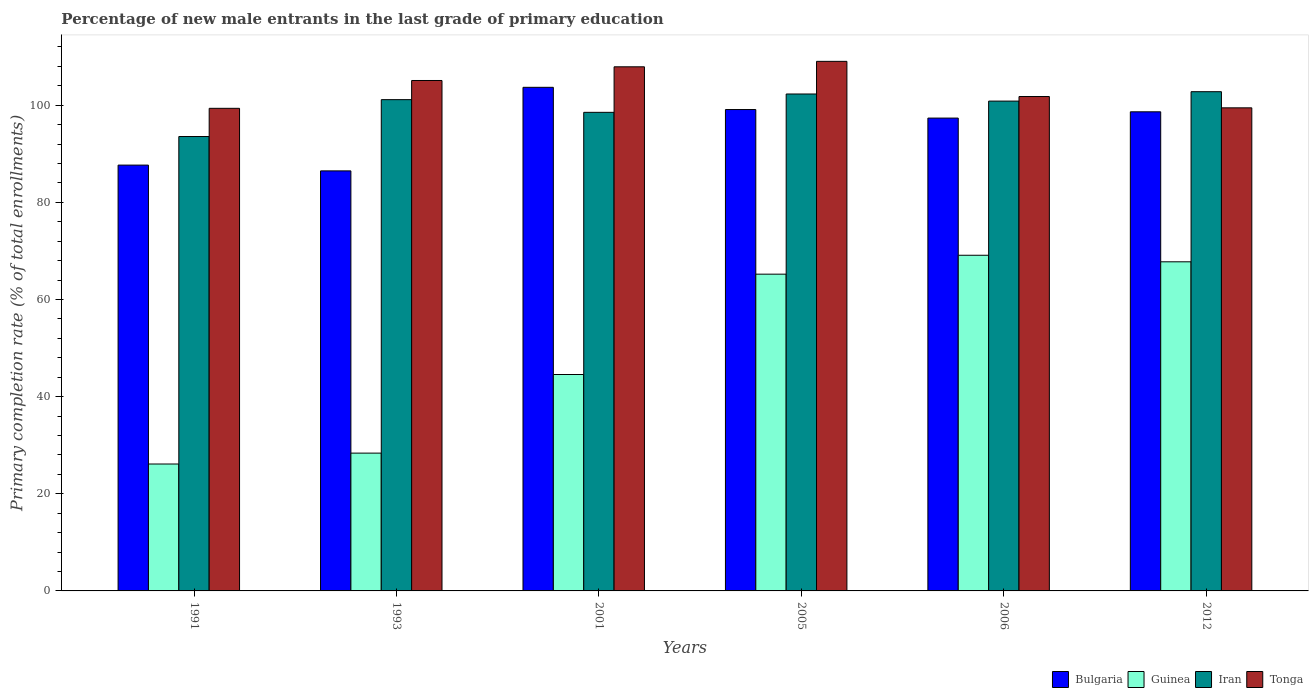How many different coloured bars are there?
Make the answer very short. 4. How many groups of bars are there?
Make the answer very short. 6. What is the label of the 1st group of bars from the left?
Your response must be concise. 1991. In how many cases, is the number of bars for a given year not equal to the number of legend labels?
Your answer should be compact. 0. What is the percentage of new male entrants in Tonga in 2012?
Give a very brief answer. 99.47. Across all years, what is the maximum percentage of new male entrants in Iran?
Your response must be concise. 102.79. Across all years, what is the minimum percentage of new male entrants in Bulgaria?
Provide a succinct answer. 86.49. In which year was the percentage of new male entrants in Bulgaria minimum?
Make the answer very short. 1993. What is the total percentage of new male entrants in Iran in the graph?
Your answer should be compact. 599.23. What is the difference between the percentage of new male entrants in Guinea in 2005 and that in 2006?
Provide a succinct answer. -3.9. What is the difference between the percentage of new male entrants in Guinea in 2005 and the percentage of new male entrants in Iran in 2012?
Your response must be concise. -37.57. What is the average percentage of new male entrants in Tonga per year?
Keep it short and to the point. 103.78. In the year 2012, what is the difference between the percentage of new male entrants in Iran and percentage of new male entrants in Tonga?
Your answer should be very brief. 3.32. In how many years, is the percentage of new male entrants in Iran greater than 108 %?
Offer a very short reply. 0. What is the ratio of the percentage of new male entrants in Guinea in 2001 to that in 2012?
Offer a very short reply. 0.66. What is the difference between the highest and the second highest percentage of new male entrants in Guinea?
Your answer should be very brief. 1.35. What is the difference between the highest and the lowest percentage of new male entrants in Iran?
Offer a terse response. 9.23. In how many years, is the percentage of new male entrants in Guinea greater than the average percentage of new male entrants in Guinea taken over all years?
Keep it short and to the point. 3. What does the 3rd bar from the left in 2006 represents?
Your response must be concise. Iran. What does the 3rd bar from the right in 2012 represents?
Your answer should be compact. Guinea. How many years are there in the graph?
Offer a terse response. 6. Are the values on the major ticks of Y-axis written in scientific E-notation?
Make the answer very short. No. Does the graph contain grids?
Offer a very short reply. No. How many legend labels are there?
Ensure brevity in your answer.  4. How are the legend labels stacked?
Provide a short and direct response. Horizontal. What is the title of the graph?
Provide a short and direct response. Percentage of new male entrants in the last grade of primary education. What is the label or title of the Y-axis?
Your answer should be very brief. Primary completion rate (% of total enrollments). What is the Primary completion rate (% of total enrollments) of Bulgaria in 1991?
Your answer should be compact. 87.68. What is the Primary completion rate (% of total enrollments) in Guinea in 1991?
Offer a terse response. 26.13. What is the Primary completion rate (% of total enrollments) of Iran in 1991?
Provide a succinct answer. 93.56. What is the Primary completion rate (% of total enrollments) in Tonga in 1991?
Keep it short and to the point. 99.37. What is the Primary completion rate (% of total enrollments) of Bulgaria in 1993?
Make the answer very short. 86.49. What is the Primary completion rate (% of total enrollments) of Guinea in 1993?
Offer a terse response. 28.37. What is the Primary completion rate (% of total enrollments) of Iran in 1993?
Keep it short and to the point. 101.15. What is the Primary completion rate (% of total enrollments) in Tonga in 1993?
Ensure brevity in your answer.  105.1. What is the Primary completion rate (% of total enrollments) of Bulgaria in 2001?
Your response must be concise. 103.7. What is the Primary completion rate (% of total enrollments) in Guinea in 2001?
Your answer should be very brief. 44.56. What is the Primary completion rate (% of total enrollments) in Iran in 2001?
Offer a terse response. 98.54. What is the Primary completion rate (% of total enrollments) of Tonga in 2001?
Ensure brevity in your answer.  107.92. What is the Primary completion rate (% of total enrollments) in Bulgaria in 2005?
Your answer should be very brief. 99.12. What is the Primary completion rate (% of total enrollments) in Guinea in 2005?
Your answer should be very brief. 65.22. What is the Primary completion rate (% of total enrollments) of Iran in 2005?
Provide a succinct answer. 102.32. What is the Primary completion rate (% of total enrollments) in Tonga in 2005?
Keep it short and to the point. 109.04. What is the Primary completion rate (% of total enrollments) in Bulgaria in 2006?
Provide a succinct answer. 97.36. What is the Primary completion rate (% of total enrollments) in Guinea in 2006?
Provide a short and direct response. 69.12. What is the Primary completion rate (% of total enrollments) in Iran in 2006?
Keep it short and to the point. 100.86. What is the Primary completion rate (% of total enrollments) in Tonga in 2006?
Your response must be concise. 101.8. What is the Primary completion rate (% of total enrollments) in Bulgaria in 2012?
Your answer should be very brief. 98.65. What is the Primary completion rate (% of total enrollments) of Guinea in 2012?
Ensure brevity in your answer.  67.77. What is the Primary completion rate (% of total enrollments) in Iran in 2012?
Your response must be concise. 102.79. What is the Primary completion rate (% of total enrollments) in Tonga in 2012?
Your answer should be very brief. 99.47. Across all years, what is the maximum Primary completion rate (% of total enrollments) in Bulgaria?
Your response must be concise. 103.7. Across all years, what is the maximum Primary completion rate (% of total enrollments) in Guinea?
Offer a terse response. 69.12. Across all years, what is the maximum Primary completion rate (% of total enrollments) in Iran?
Your answer should be compact. 102.79. Across all years, what is the maximum Primary completion rate (% of total enrollments) in Tonga?
Your response must be concise. 109.04. Across all years, what is the minimum Primary completion rate (% of total enrollments) of Bulgaria?
Give a very brief answer. 86.49. Across all years, what is the minimum Primary completion rate (% of total enrollments) of Guinea?
Your answer should be very brief. 26.13. Across all years, what is the minimum Primary completion rate (% of total enrollments) of Iran?
Your answer should be compact. 93.56. Across all years, what is the minimum Primary completion rate (% of total enrollments) of Tonga?
Keep it short and to the point. 99.37. What is the total Primary completion rate (% of total enrollments) of Bulgaria in the graph?
Ensure brevity in your answer.  572.99. What is the total Primary completion rate (% of total enrollments) in Guinea in the graph?
Keep it short and to the point. 301.17. What is the total Primary completion rate (% of total enrollments) of Iran in the graph?
Give a very brief answer. 599.23. What is the total Primary completion rate (% of total enrollments) in Tonga in the graph?
Make the answer very short. 622.7. What is the difference between the Primary completion rate (% of total enrollments) in Bulgaria in 1991 and that in 1993?
Ensure brevity in your answer.  1.19. What is the difference between the Primary completion rate (% of total enrollments) of Guinea in 1991 and that in 1993?
Offer a terse response. -2.24. What is the difference between the Primary completion rate (% of total enrollments) in Iran in 1991 and that in 1993?
Your answer should be compact. -7.59. What is the difference between the Primary completion rate (% of total enrollments) of Tonga in 1991 and that in 1993?
Give a very brief answer. -5.73. What is the difference between the Primary completion rate (% of total enrollments) in Bulgaria in 1991 and that in 2001?
Your answer should be compact. -16.02. What is the difference between the Primary completion rate (% of total enrollments) of Guinea in 1991 and that in 2001?
Keep it short and to the point. -18.43. What is the difference between the Primary completion rate (% of total enrollments) of Iran in 1991 and that in 2001?
Your response must be concise. -4.98. What is the difference between the Primary completion rate (% of total enrollments) of Tonga in 1991 and that in 2001?
Your answer should be very brief. -8.55. What is the difference between the Primary completion rate (% of total enrollments) in Bulgaria in 1991 and that in 2005?
Your answer should be very brief. -11.44. What is the difference between the Primary completion rate (% of total enrollments) of Guinea in 1991 and that in 2005?
Your response must be concise. -39.09. What is the difference between the Primary completion rate (% of total enrollments) in Iran in 1991 and that in 2005?
Your response must be concise. -8.76. What is the difference between the Primary completion rate (% of total enrollments) of Tonga in 1991 and that in 2005?
Ensure brevity in your answer.  -9.67. What is the difference between the Primary completion rate (% of total enrollments) of Bulgaria in 1991 and that in 2006?
Make the answer very short. -9.68. What is the difference between the Primary completion rate (% of total enrollments) in Guinea in 1991 and that in 2006?
Your answer should be very brief. -42.98. What is the difference between the Primary completion rate (% of total enrollments) of Iran in 1991 and that in 2006?
Provide a short and direct response. -7.29. What is the difference between the Primary completion rate (% of total enrollments) in Tonga in 1991 and that in 2006?
Make the answer very short. -2.43. What is the difference between the Primary completion rate (% of total enrollments) in Bulgaria in 1991 and that in 2012?
Make the answer very short. -10.97. What is the difference between the Primary completion rate (% of total enrollments) in Guinea in 1991 and that in 2012?
Offer a terse response. -41.63. What is the difference between the Primary completion rate (% of total enrollments) in Iran in 1991 and that in 2012?
Offer a terse response. -9.23. What is the difference between the Primary completion rate (% of total enrollments) of Tonga in 1991 and that in 2012?
Ensure brevity in your answer.  -0.1. What is the difference between the Primary completion rate (% of total enrollments) of Bulgaria in 1993 and that in 2001?
Your answer should be very brief. -17.21. What is the difference between the Primary completion rate (% of total enrollments) of Guinea in 1993 and that in 2001?
Your answer should be compact. -16.19. What is the difference between the Primary completion rate (% of total enrollments) of Iran in 1993 and that in 2001?
Offer a very short reply. 2.61. What is the difference between the Primary completion rate (% of total enrollments) of Tonga in 1993 and that in 2001?
Offer a terse response. -2.82. What is the difference between the Primary completion rate (% of total enrollments) of Bulgaria in 1993 and that in 2005?
Offer a very short reply. -12.63. What is the difference between the Primary completion rate (% of total enrollments) in Guinea in 1993 and that in 2005?
Make the answer very short. -36.85. What is the difference between the Primary completion rate (% of total enrollments) of Iran in 1993 and that in 2005?
Your response must be concise. -1.16. What is the difference between the Primary completion rate (% of total enrollments) of Tonga in 1993 and that in 2005?
Your answer should be very brief. -3.94. What is the difference between the Primary completion rate (% of total enrollments) in Bulgaria in 1993 and that in 2006?
Your answer should be compact. -10.87. What is the difference between the Primary completion rate (% of total enrollments) of Guinea in 1993 and that in 2006?
Provide a short and direct response. -40.74. What is the difference between the Primary completion rate (% of total enrollments) of Iran in 1993 and that in 2006?
Ensure brevity in your answer.  0.3. What is the difference between the Primary completion rate (% of total enrollments) in Tonga in 1993 and that in 2006?
Your answer should be compact. 3.3. What is the difference between the Primary completion rate (% of total enrollments) in Bulgaria in 1993 and that in 2012?
Your answer should be compact. -12.16. What is the difference between the Primary completion rate (% of total enrollments) in Guinea in 1993 and that in 2012?
Provide a short and direct response. -39.39. What is the difference between the Primary completion rate (% of total enrollments) in Iran in 1993 and that in 2012?
Make the answer very short. -1.64. What is the difference between the Primary completion rate (% of total enrollments) in Tonga in 1993 and that in 2012?
Offer a very short reply. 5.63. What is the difference between the Primary completion rate (% of total enrollments) of Bulgaria in 2001 and that in 2005?
Keep it short and to the point. 4.58. What is the difference between the Primary completion rate (% of total enrollments) of Guinea in 2001 and that in 2005?
Your answer should be very brief. -20.66. What is the difference between the Primary completion rate (% of total enrollments) of Iran in 2001 and that in 2005?
Provide a succinct answer. -3.78. What is the difference between the Primary completion rate (% of total enrollments) in Tonga in 2001 and that in 2005?
Ensure brevity in your answer.  -1.12. What is the difference between the Primary completion rate (% of total enrollments) in Bulgaria in 2001 and that in 2006?
Your answer should be compact. 6.34. What is the difference between the Primary completion rate (% of total enrollments) in Guinea in 2001 and that in 2006?
Make the answer very short. -24.56. What is the difference between the Primary completion rate (% of total enrollments) of Iran in 2001 and that in 2006?
Offer a very short reply. -2.31. What is the difference between the Primary completion rate (% of total enrollments) in Tonga in 2001 and that in 2006?
Provide a succinct answer. 6.12. What is the difference between the Primary completion rate (% of total enrollments) in Bulgaria in 2001 and that in 2012?
Provide a succinct answer. 5.04. What is the difference between the Primary completion rate (% of total enrollments) in Guinea in 2001 and that in 2012?
Offer a very short reply. -23.21. What is the difference between the Primary completion rate (% of total enrollments) in Iran in 2001 and that in 2012?
Make the answer very short. -4.25. What is the difference between the Primary completion rate (% of total enrollments) in Tonga in 2001 and that in 2012?
Provide a short and direct response. 8.45. What is the difference between the Primary completion rate (% of total enrollments) of Bulgaria in 2005 and that in 2006?
Provide a short and direct response. 1.76. What is the difference between the Primary completion rate (% of total enrollments) of Guinea in 2005 and that in 2006?
Offer a terse response. -3.9. What is the difference between the Primary completion rate (% of total enrollments) of Iran in 2005 and that in 2006?
Your response must be concise. 1.46. What is the difference between the Primary completion rate (% of total enrollments) in Tonga in 2005 and that in 2006?
Your response must be concise. 7.24. What is the difference between the Primary completion rate (% of total enrollments) of Bulgaria in 2005 and that in 2012?
Your answer should be compact. 0.47. What is the difference between the Primary completion rate (% of total enrollments) of Guinea in 2005 and that in 2012?
Offer a very short reply. -2.55. What is the difference between the Primary completion rate (% of total enrollments) in Iran in 2005 and that in 2012?
Give a very brief answer. -0.47. What is the difference between the Primary completion rate (% of total enrollments) in Tonga in 2005 and that in 2012?
Your response must be concise. 9.57. What is the difference between the Primary completion rate (% of total enrollments) of Bulgaria in 2006 and that in 2012?
Ensure brevity in your answer.  -1.29. What is the difference between the Primary completion rate (% of total enrollments) of Guinea in 2006 and that in 2012?
Give a very brief answer. 1.35. What is the difference between the Primary completion rate (% of total enrollments) in Iran in 2006 and that in 2012?
Offer a terse response. -1.94. What is the difference between the Primary completion rate (% of total enrollments) in Tonga in 2006 and that in 2012?
Offer a terse response. 2.33. What is the difference between the Primary completion rate (% of total enrollments) in Bulgaria in 1991 and the Primary completion rate (% of total enrollments) in Guinea in 1993?
Keep it short and to the point. 59.31. What is the difference between the Primary completion rate (% of total enrollments) in Bulgaria in 1991 and the Primary completion rate (% of total enrollments) in Iran in 1993?
Provide a succinct answer. -13.48. What is the difference between the Primary completion rate (% of total enrollments) of Bulgaria in 1991 and the Primary completion rate (% of total enrollments) of Tonga in 1993?
Provide a short and direct response. -17.42. What is the difference between the Primary completion rate (% of total enrollments) in Guinea in 1991 and the Primary completion rate (% of total enrollments) in Iran in 1993?
Your answer should be very brief. -75.02. What is the difference between the Primary completion rate (% of total enrollments) of Guinea in 1991 and the Primary completion rate (% of total enrollments) of Tonga in 1993?
Keep it short and to the point. -78.97. What is the difference between the Primary completion rate (% of total enrollments) in Iran in 1991 and the Primary completion rate (% of total enrollments) in Tonga in 1993?
Keep it short and to the point. -11.54. What is the difference between the Primary completion rate (% of total enrollments) of Bulgaria in 1991 and the Primary completion rate (% of total enrollments) of Guinea in 2001?
Offer a very short reply. 43.12. What is the difference between the Primary completion rate (% of total enrollments) of Bulgaria in 1991 and the Primary completion rate (% of total enrollments) of Iran in 2001?
Your answer should be very brief. -10.86. What is the difference between the Primary completion rate (% of total enrollments) in Bulgaria in 1991 and the Primary completion rate (% of total enrollments) in Tonga in 2001?
Provide a succinct answer. -20.24. What is the difference between the Primary completion rate (% of total enrollments) in Guinea in 1991 and the Primary completion rate (% of total enrollments) in Iran in 2001?
Your answer should be compact. -72.41. What is the difference between the Primary completion rate (% of total enrollments) of Guinea in 1991 and the Primary completion rate (% of total enrollments) of Tonga in 2001?
Offer a terse response. -81.78. What is the difference between the Primary completion rate (% of total enrollments) in Iran in 1991 and the Primary completion rate (% of total enrollments) in Tonga in 2001?
Provide a short and direct response. -14.35. What is the difference between the Primary completion rate (% of total enrollments) in Bulgaria in 1991 and the Primary completion rate (% of total enrollments) in Guinea in 2005?
Ensure brevity in your answer.  22.46. What is the difference between the Primary completion rate (% of total enrollments) in Bulgaria in 1991 and the Primary completion rate (% of total enrollments) in Iran in 2005?
Ensure brevity in your answer.  -14.64. What is the difference between the Primary completion rate (% of total enrollments) in Bulgaria in 1991 and the Primary completion rate (% of total enrollments) in Tonga in 2005?
Your answer should be very brief. -21.36. What is the difference between the Primary completion rate (% of total enrollments) in Guinea in 1991 and the Primary completion rate (% of total enrollments) in Iran in 2005?
Provide a succinct answer. -76.19. What is the difference between the Primary completion rate (% of total enrollments) of Guinea in 1991 and the Primary completion rate (% of total enrollments) of Tonga in 2005?
Your answer should be compact. -82.91. What is the difference between the Primary completion rate (% of total enrollments) of Iran in 1991 and the Primary completion rate (% of total enrollments) of Tonga in 2005?
Offer a terse response. -15.48. What is the difference between the Primary completion rate (% of total enrollments) in Bulgaria in 1991 and the Primary completion rate (% of total enrollments) in Guinea in 2006?
Offer a very short reply. 18.56. What is the difference between the Primary completion rate (% of total enrollments) in Bulgaria in 1991 and the Primary completion rate (% of total enrollments) in Iran in 2006?
Ensure brevity in your answer.  -13.18. What is the difference between the Primary completion rate (% of total enrollments) of Bulgaria in 1991 and the Primary completion rate (% of total enrollments) of Tonga in 2006?
Your answer should be compact. -14.12. What is the difference between the Primary completion rate (% of total enrollments) in Guinea in 1991 and the Primary completion rate (% of total enrollments) in Iran in 2006?
Make the answer very short. -74.72. What is the difference between the Primary completion rate (% of total enrollments) in Guinea in 1991 and the Primary completion rate (% of total enrollments) in Tonga in 2006?
Provide a short and direct response. -75.67. What is the difference between the Primary completion rate (% of total enrollments) in Iran in 1991 and the Primary completion rate (% of total enrollments) in Tonga in 2006?
Give a very brief answer. -8.24. What is the difference between the Primary completion rate (% of total enrollments) in Bulgaria in 1991 and the Primary completion rate (% of total enrollments) in Guinea in 2012?
Provide a succinct answer. 19.91. What is the difference between the Primary completion rate (% of total enrollments) in Bulgaria in 1991 and the Primary completion rate (% of total enrollments) in Iran in 2012?
Ensure brevity in your answer.  -15.11. What is the difference between the Primary completion rate (% of total enrollments) in Bulgaria in 1991 and the Primary completion rate (% of total enrollments) in Tonga in 2012?
Your response must be concise. -11.79. What is the difference between the Primary completion rate (% of total enrollments) of Guinea in 1991 and the Primary completion rate (% of total enrollments) of Iran in 2012?
Make the answer very short. -76.66. What is the difference between the Primary completion rate (% of total enrollments) in Guinea in 1991 and the Primary completion rate (% of total enrollments) in Tonga in 2012?
Provide a short and direct response. -73.34. What is the difference between the Primary completion rate (% of total enrollments) in Iran in 1991 and the Primary completion rate (% of total enrollments) in Tonga in 2012?
Make the answer very short. -5.91. What is the difference between the Primary completion rate (% of total enrollments) in Bulgaria in 1993 and the Primary completion rate (% of total enrollments) in Guinea in 2001?
Your answer should be very brief. 41.93. What is the difference between the Primary completion rate (% of total enrollments) in Bulgaria in 1993 and the Primary completion rate (% of total enrollments) in Iran in 2001?
Give a very brief answer. -12.05. What is the difference between the Primary completion rate (% of total enrollments) of Bulgaria in 1993 and the Primary completion rate (% of total enrollments) of Tonga in 2001?
Give a very brief answer. -21.43. What is the difference between the Primary completion rate (% of total enrollments) of Guinea in 1993 and the Primary completion rate (% of total enrollments) of Iran in 2001?
Your response must be concise. -70.17. What is the difference between the Primary completion rate (% of total enrollments) of Guinea in 1993 and the Primary completion rate (% of total enrollments) of Tonga in 2001?
Keep it short and to the point. -79.54. What is the difference between the Primary completion rate (% of total enrollments) in Iran in 1993 and the Primary completion rate (% of total enrollments) in Tonga in 2001?
Give a very brief answer. -6.76. What is the difference between the Primary completion rate (% of total enrollments) in Bulgaria in 1993 and the Primary completion rate (% of total enrollments) in Guinea in 2005?
Provide a succinct answer. 21.27. What is the difference between the Primary completion rate (% of total enrollments) in Bulgaria in 1993 and the Primary completion rate (% of total enrollments) in Iran in 2005?
Offer a very short reply. -15.83. What is the difference between the Primary completion rate (% of total enrollments) in Bulgaria in 1993 and the Primary completion rate (% of total enrollments) in Tonga in 2005?
Provide a succinct answer. -22.55. What is the difference between the Primary completion rate (% of total enrollments) of Guinea in 1993 and the Primary completion rate (% of total enrollments) of Iran in 2005?
Give a very brief answer. -73.95. What is the difference between the Primary completion rate (% of total enrollments) of Guinea in 1993 and the Primary completion rate (% of total enrollments) of Tonga in 2005?
Offer a very short reply. -80.67. What is the difference between the Primary completion rate (% of total enrollments) in Iran in 1993 and the Primary completion rate (% of total enrollments) in Tonga in 2005?
Offer a terse response. -7.89. What is the difference between the Primary completion rate (% of total enrollments) in Bulgaria in 1993 and the Primary completion rate (% of total enrollments) in Guinea in 2006?
Your response must be concise. 17.37. What is the difference between the Primary completion rate (% of total enrollments) in Bulgaria in 1993 and the Primary completion rate (% of total enrollments) in Iran in 2006?
Give a very brief answer. -14.37. What is the difference between the Primary completion rate (% of total enrollments) of Bulgaria in 1993 and the Primary completion rate (% of total enrollments) of Tonga in 2006?
Offer a terse response. -15.31. What is the difference between the Primary completion rate (% of total enrollments) of Guinea in 1993 and the Primary completion rate (% of total enrollments) of Iran in 2006?
Make the answer very short. -72.48. What is the difference between the Primary completion rate (% of total enrollments) in Guinea in 1993 and the Primary completion rate (% of total enrollments) in Tonga in 2006?
Make the answer very short. -73.43. What is the difference between the Primary completion rate (% of total enrollments) in Iran in 1993 and the Primary completion rate (% of total enrollments) in Tonga in 2006?
Provide a short and direct response. -0.64. What is the difference between the Primary completion rate (% of total enrollments) of Bulgaria in 1993 and the Primary completion rate (% of total enrollments) of Guinea in 2012?
Offer a very short reply. 18.72. What is the difference between the Primary completion rate (% of total enrollments) of Bulgaria in 1993 and the Primary completion rate (% of total enrollments) of Iran in 2012?
Offer a terse response. -16.3. What is the difference between the Primary completion rate (% of total enrollments) of Bulgaria in 1993 and the Primary completion rate (% of total enrollments) of Tonga in 2012?
Your response must be concise. -12.98. What is the difference between the Primary completion rate (% of total enrollments) in Guinea in 1993 and the Primary completion rate (% of total enrollments) in Iran in 2012?
Ensure brevity in your answer.  -74.42. What is the difference between the Primary completion rate (% of total enrollments) of Guinea in 1993 and the Primary completion rate (% of total enrollments) of Tonga in 2012?
Your answer should be compact. -71.1. What is the difference between the Primary completion rate (% of total enrollments) in Iran in 1993 and the Primary completion rate (% of total enrollments) in Tonga in 2012?
Provide a short and direct response. 1.69. What is the difference between the Primary completion rate (% of total enrollments) in Bulgaria in 2001 and the Primary completion rate (% of total enrollments) in Guinea in 2005?
Offer a very short reply. 38.47. What is the difference between the Primary completion rate (% of total enrollments) in Bulgaria in 2001 and the Primary completion rate (% of total enrollments) in Iran in 2005?
Your answer should be compact. 1.38. What is the difference between the Primary completion rate (% of total enrollments) of Bulgaria in 2001 and the Primary completion rate (% of total enrollments) of Tonga in 2005?
Make the answer very short. -5.35. What is the difference between the Primary completion rate (% of total enrollments) of Guinea in 2001 and the Primary completion rate (% of total enrollments) of Iran in 2005?
Your response must be concise. -57.76. What is the difference between the Primary completion rate (% of total enrollments) in Guinea in 2001 and the Primary completion rate (% of total enrollments) in Tonga in 2005?
Offer a terse response. -64.48. What is the difference between the Primary completion rate (% of total enrollments) in Iran in 2001 and the Primary completion rate (% of total enrollments) in Tonga in 2005?
Offer a terse response. -10.5. What is the difference between the Primary completion rate (% of total enrollments) of Bulgaria in 2001 and the Primary completion rate (% of total enrollments) of Guinea in 2006?
Give a very brief answer. 34.58. What is the difference between the Primary completion rate (% of total enrollments) in Bulgaria in 2001 and the Primary completion rate (% of total enrollments) in Iran in 2006?
Your answer should be compact. 2.84. What is the difference between the Primary completion rate (% of total enrollments) of Bulgaria in 2001 and the Primary completion rate (% of total enrollments) of Tonga in 2006?
Make the answer very short. 1.9. What is the difference between the Primary completion rate (% of total enrollments) of Guinea in 2001 and the Primary completion rate (% of total enrollments) of Iran in 2006?
Offer a very short reply. -56.3. What is the difference between the Primary completion rate (% of total enrollments) in Guinea in 2001 and the Primary completion rate (% of total enrollments) in Tonga in 2006?
Ensure brevity in your answer.  -57.24. What is the difference between the Primary completion rate (% of total enrollments) in Iran in 2001 and the Primary completion rate (% of total enrollments) in Tonga in 2006?
Keep it short and to the point. -3.26. What is the difference between the Primary completion rate (% of total enrollments) of Bulgaria in 2001 and the Primary completion rate (% of total enrollments) of Guinea in 2012?
Provide a short and direct response. 35.93. What is the difference between the Primary completion rate (% of total enrollments) of Bulgaria in 2001 and the Primary completion rate (% of total enrollments) of Iran in 2012?
Provide a succinct answer. 0.9. What is the difference between the Primary completion rate (% of total enrollments) in Bulgaria in 2001 and the Primary completion rate (% of total enrollments) in Tonga in 2012?
Provide a succinct answer. 4.23. What is the difference between the Primary completion rate (% of total enrollments) of Guinea in 2001 and the Primary completion rate (% of total enrollments) of Iran in 2012?
Ensure brevity in your answer.  -58.23. What is the difference between the Primary completion rate (% of total enrollments) of Guinea in 2001 and the Primary completion rate (% of total enrollments) of Tonga in 2012?
Give a very brief answer. -54.91. What is the difference between the Primary completion rate (% of total enrollments) in Iran in 2001 and the Primary completion rate (% of total enrollments) in Tonga in 2012?
Keep it short and to the point. -0.93. What is the difference between the Primary completion rate (% of total enrollments) of Bulgaria in 2005 and the Primary completion rate (% of total enrollments) of Guinea in 2006?
Offer a very short reply. 30. What is the difference between the Primary completion rate (% of total enrollments) in Bulgaria in 2005 and the Primary completion rate (% of total enrollments) in Iran in 2006?
Provide a succinct answer. -1.74. What is the difference between the Primary completion rate (% of total enrollments) in Bulgaria in 2005 and the Primary completion rate (% of total enrollments) in Tonga in 2006?
Provide a succinct answer. -2.68. What is the difference between the Primary completion rate (% of total enrollments) in Guinea in 2005 and the Primary completion rate (% of total enrollments) in Iran in 2006?
Provide a short and direct response. -35.63. What is the difference between the Primary completion rate (% of total enrollments) of Guinea in 2005 and the Primary completion rate (% of total enrollments) of Tonga in 2006?
Make the answer very short. -36.58. What is the difference between the Primary completion rate (% of total enrollments) of Iran in 2005 and the Primary completion rate (% of total enrollments) of Tonga in 2006?
Your answer should be very brief. 0.52. What is the difference between the Primary completion rate (% of total enrollments) of Bulgaria in 2005 and the Primary completion rate (% of total enrollments) of Guinea in 2012?
Your answer should be very brief. 31.35. What is the difference between the Primary completion rate (% of total enrollments) in Bulgaria in 2005 and the Primary completion rate (% of total enrollments) in Iran in 2012?
Your response must be concise. -3.67. What is the difference between the Primary completion rate (% of total enrollments) of Bulgaria in 2005 and the Primary completion rate (% of total enrollments) of Tonga in 2012?
Give a very brief answer. -0.35. What is the difference between the Primary completion rate (% of total enrollments) of Guinea in 2005 and the Primary completion rate (% of total enrollments) of Iran in 2012?
Offer a very short reply. -37.57. What is the difference between the Primary completion rate (% of total enrollments) in Guinea in 2005 and the Primary completion rate (% of total enrollments) in Tonga in 2012?
Your answer should be very brief. -34.25. What is the difference between the Primary completion rate (% of total enrollments) of Iran in 2005 and the Primary completion rate (% of total enrollments) of Tonga in 2012?
Make the answer very short. 2.85. What is the difference between the Primary completion rate (% of total enrollments) of Bulgaria in 2006 and the Primary completion rate (% of total enrollments) of Guinea in 2012?
Offer a terse response. 29.59. What is the difference between the Primary completion rate (% of total enrollments) in Bulgaria in 2006 and the Primary completion rate (% of total enrollments) in Iran in 2012?
Keep it short and to the point. -5.43. What is the difference between the Primary completion rate (% of total enrollments) in Bulgaria in 2006 and the Primary completion rate (% of total enrollments) in Tonga in 2012?
Provide a succinct answer. -2.11. What is the difference between the Primary completion rate (% of total enrollments) of Guinea in 2006 and the Primary completion rate (% of total enrollments) of Iran in 2012?
Make the answer very short. -33.68. What is the difference between the Primary completion rate (% of total enrollments) of Guinea in 2006 and the Primary completion rate (% of total enrollments) of Tonga in 2012?
Make the answer very short. -30.35. What is the difference between the Primary completion rate (% of total enrollments) of Iran in 2006 and the Primary completion rate (% of total enrollments) of Tonga in 2012?
Make the answer very short. 1.39. What is the average Primary completion rate (% of total enrollments) of Bulgaria per year?
Give a very brief answer. 95.5. What is the average Primary completion rate (% of total enrollments) in Guinea per year?
Your answer should be compact. 50.2. What is the average Primary completion rate (% of total enrollments) of Iran per year?
Your response must be concise. 99.87. What is the average Primary completion rate (% of total enrollments) of Tonga per year?
Give a very brief answer. 103.78. In the year 1991, what is the difference between the Primary completion rate (% of total enrollments) in Bulgaria and Primary completion rate (% of total enrollments) in Guinea?
Keep it short and to the point. 61.55. In the year 1991, what is the difference between the Primary completion rate (% of total enrollments) of Bulgaria and Primary completion rate (% of total enrollments) of Iran?
Provide a short and direct response. -5.89. In the year 1991, what is the difference between the Primary completion rate (% of total enrollments) of Bulgaria and Primary completion rate (% of total enrollments) of Tonga?
Keep it short and to the point. -11.69. In the year 1991, what is the difference between the Primary completion rate (% of total enrollments) of Guinea and Primary completion rate (% of total enrollments) of Iran?
Give a very brief answer. -67.43. In the year 1991, what is the difference between the Primary completion rate (% of total enrollments) of Guinea and Primary completion rate (% of total enrollments) of Tonga?
Give a very brief answer. -73.24. In the year 1991, what is the difference between the Primary completion rate (% of total enrollments) in Iran and Primary completion rate (% of total enrollments) in Tonga?
Your answer should be very brief. -5.81. In the year 1993, what is the difference between the Primary completion rate (% of total enrollments) in Bulgaria and Primary completion rate (% of total enrollments) in Guinea?
Keep it short and to the point. 58.12. In the year 1993, what is the difference between the Primary completion rate (% of total enrollments) in Bulgaria and Primary completion rate (% of total enrollments) in Iran?
Offer a terse response. -14.67. In the year 1993, what is the difference between the Primary completion rate (% of total enrollments) of Bulgaria and Primary completion rate (% of total enrollments) of Tonga?
Make the answer very short. -18.61. In the year 1993, what is the difference between the Primary completion rate (% of total enrollments) in Guinea and Primary completion rate (% of total enrollments) in Iran?
Give a very brief answer. -72.78. In the year 1993, what is the difference between the Primary completion rate (% of total enrollments) of Guinea and Primary completion rate (% of total enrollments) of Tonga?
Your answer should be compact. -76.73. In the year 1993, what is the difference between the Primary completion rate (% of total enrollments) in Iran and Primary completion rate (% of total enrollments) in Tonga?
Keep it short and to the point. -3.94. In the year 2001, what is the difference between the Primary completion rate (% of total enrollments) of Bulgaria and Primary completion rate (% of total enrollments) of Guinea?
Your answer should be compact. 59.14. In the year 2001, what is the difference between the Primary completion rate (% of total enrollments) in Bulgaria and Primary completion rate (% of total enrollments) in Iran?
Your answer should be very brief. 5.15. In the year 2001, what is the difference between the Primary completion rate (% of total enrollments) in Bulgaria and Primary completion rate (% of total enrollments) in Tonga?
Ensure brevity in your answer.  -4.22. In the year 2001, what is the difference between the Primary completion rate (% of total enrollments) in Guinea and Primary completion rate (% of total enrollments) in Iran?
Your answer should be compact. -53.98. In the year 2001, what is the difference between the Primary completion rate (% of total enrollments) in Guinea and Primary completion rate (% of total enrollments) in Tonga?
Your answer should be very brief. -63.36. In the year 2001, what is the difference between the Primary completion rate (% of total enrollments) of Iran and Primary completion rate (% of total enrollments) of Tonga?
Your answer should be very brief. -9.38. In the year 2005, what is the difference between the Primary completion rate (% of total enrollments) of Bulgaria and Primary completion rate (% of total enrollments) of Guinea?
Ensure brevity in your answer.  33.9. In the year 2005, what is the difference between the Primary completion rate (% of total enrollments) of Bulgaria and Primary completion rate (% of total enrollments) of Iran?
Offer a terse response. -3.2. In the year 2005, what is the difference between the Primary completion rate (% of total enrollments) in Bulgaria and Primary completion rate (% of total enrollments) in Tonga?
Give a very brief answer. -9.92. In the year 2005, what is the difference between the Primary completion rate (% of total enrollments) of Guinea and Primary completion rate (% of total enrollments) of Iran?
Offer a very short reply. -37.1. In the year 2005, what is the difference between the Primary completion rate (% of total enrollments) of Guinea and Primary completion rate (% of total enrollments) of Tonga?
Give a very brief answer. -43.82. In the year 2005, what is the difference between the Primary completion rate (% of total enrollments) in Iran and Primary completion rate (% of total enrollments) in Tonga?
Give a very brief answer. -6.72. In the year 2006, what is the difference between the Primary completion rate (% of total enrollments) of Bulgaria and Primary completion rate (% of total enrollments) of Guinea?
Your answer should be compact. 28.24. In the year 2006, what is the difference between the Primary completion rate (% of total enrollments) in Bulgaria and Primary completion rate (% of total enrollments) in Iran?
Your response must be concise. -3.5. In the year 2006, what is the difference between the Primary completion rate (% of total enrollments) in Bulgaria and Primary completion rate (% of total enrollments) in Tonga?
Make the answer very short. -4.44. In the year 2006, what is the difference between the Primary completion rate (% of total enrollments) of Guinea and Primary completion rate (% of total enrollments) of Iran?
Offer a very short reply. -31.74. In the year 2006, what is the difference between the Primary completion rate (% of total enrollments) in Guinea and Primary completion rate (% of total enrollments) in Tonga?
Ensure brevity in your answer.  -32.68. In the year 2006, what is the difference between the Primary completion rate (% of total enrollments) of Iran and Primary completion rate (% of total enrollments) of Tonga?
Provide a short and direct response. -0.94. In the year 2012, what is the difference between the Primary completion rate (% of total enrollments) in Bulgaria and Primary completion rate (% of total enrollments) in Guinea?
Offer a terse response. 30.89. In the year 2012, what is the difference between the Primary completion rate (% of total enrollments) in Bulgaria and Primary completion rate (% of total enrollments) in Iran?
Your answer should be compact. -4.14. In the year 2012, what is the difference between the Primary completion rate (% of total enrollments) in Bulgaria and Primary completion rate (% of total enrollments) in Tonga?
Provide a short and direct response. -0.82. In the year 2012, what is the difference between the Primary completion rate (% of total enrollments) in Guinea and Primary completion rate (% of total enrollments) in Iran?
Your answer should be compact. -35.03. In the year 2012, what is the difference between the Primary completion rate (% of total enrollments) in Guinea and Primary completion rate (% of total enrollments) in Tonga?
Provide a succinct answer. -31.7. In the year 2012, what is the difference between the Primary completion rate (% of total enrollments) of Iran and Primary completion rate (% of total enrollments) of Tonga?
Give a very brief answer. 3.32. What is the ratio of the Primary completion rate (% of total enrollments) in Bulgaria in 1991 to that in 1993?
Offer a very short reply. 1.01. What is the ratio of the Primary completion rate (% of total enrollments) in Guinea in 1991 to that in 1993?
Your answer should be compact. 0.92. What is the ratio of the Primary completion rate (% of total enrollments) in Iran in 1991 to that in 1993?
Your answer should be very brief. 0.93. What is the ratio of the Primary completion rate (% of total enrollments) of Tonga in 1991 to that in 1993?
Your answer should be very brief. 0.95. What is the ratio of the Primary completion rate (% of total enrollments) in Bulgaria in 1991 to that in 2001?
Offer a very short reply. 0.85. What is the ratio of the Primary completion rate (% of total enrollments) of Guinea in 1991 to that in 2001?
Keep it short and to the point. 0.59. What is the ratio of the Primary completion rate (% of total enrollments) of Iran in 1991 to that in 2001?
Provide a succinct answer. 0.95. What is the ratio of the Primary completion rate (% of total enrollments) in Tonga in 1991 to that in 2001?
Offer a very short reply. 0.92. What is the ratio of the Primary completion rate (% of total enrollments) in Bulgaria in 1991 to that in 2005?
Provide a succinct answer. 0.88. What is the ratio of the Primary completion rate (% of total enrollments) in Guinea in 1991 to that in 2005?
Offer a very short reply. 0.4. What is the ratio of the Primary completion rate (% of total enrollments) in Iran in 1991 to that in 2005?
Provide a short and direct response. 0.91. What is the ratio of the Primary completion rate (% of total enrollments) of Tonga in 1991 to that in 2005?
Your response must be concise. 0.91. What is the ratio of the Primary completion rate (% of total enrollments) in Bulgaria in 1991 to that in 2006?
Your answer should be compact. 0.9. What is the ratio of the Primary completion rate (% of total enrollments) of Guinea in 1991 to that in 2006?
Offer a terse response. 0.38. What is the ratio of the Primary completion rate (% of total enrollments) of Iran in 1991 to that in 2006?
Keep it short and to the point. 0.93. What is the ratio of the Primary completion rate (% of total enrollments) of Tonga in 1991 to that in 2006?
Provide a short and direct response. 0.98. What is the ratio of the Primary completion rate (% of total enrollments) in Bulgaria in 1991 to that in 2012?
Provide a short and direct response. 0.89. What is the ratio of the Primary completion rate (% of total enrollments) in Guinea in 1991 to that in 2012?
Give a very brief answer. 0.39. What is the ratio of the Primary completion rate (% of total enrollments) in Iran in 1991 to that in 2012?
Make the answer very short. 0.91. What is the ratio of the Primary completion rate (% of total enrollments) in Bulgaria in 1993 to that in 2001?
Ensure brevity in your answer.  0.83. What is the ratio of the Primary completion rate (% of total enrollments) of Guinea in 1993 to that in 2001?
Make the answer very short. 0.64. What is the ratio of the Primary completion rate (% of total enrollments) of Iran in 1993 to that in 2001?
Your answer should be very brief. 1.03. What is the ratio of the Primary completion rate (% of total enrollments) in Tonga in 1993 to that in 2001?
Keep it short and to the point. 0.97. What is the ratio of the Primary completion rate (% of total enrollments) in Bulgaria in 1993 to that in 2005?
Your answer should be very brief. 0.87. What is the ratio of the Primary completion rate (% of total enrollments) of Guinea in 1993 to that in 2005?
Make the answer very short. 0.43. What is the ratio of the Primary completion rate (% of total enrollments) in Iran in 1993 to that in 2005?
Your response must be concise. 0.99. What is the ratio of the Primary completion rate (% of total enrollments) in Tonga in 1993 to that in 2005?
Provide a short and direct response. 0.96. What is the ratio of the Primary completion rate (% of total enrollments) of Bulgaria in 1993 to that in 2006?
Keep it short and to the point. 0.89. What is the ratio of the Primary completion rate (% of total enrollments) in Guinea in 1993 to that in 2006?
Offer a terse response. 0.41. What is the ratio of the Primary completion rate (% of total enrollments) in Tonga in 1993 to that in 2006?
Offer a very short reply. 1.03. What is the ratio of the Primary completion rate (% of total enrollments) of Bulgaria in 1993 to that in 2012?
Your response must be concise. 0.88. What is the ratio of the Primary completion rate (% of total enrollments) in Guinea in 1993 to that in 2012?
Offer a terse response. 0.42. What is the ratio of the Primary completion rate (% of total enrollments) of Iran in 1993 to that in 2012?
Ensure brevity in your answer.  0.98. What is the ratio of the Primary completion rate (% of total enrollments) in Tonga in 1993 to that in 2012?
Make the answer very short. 1.06. What is the ratio of the Primary completion rate (% of total enrollments) of Bulgaria in 2001 to that in 2005?
Your answer should be very brief. 1.05. What is the ratio of the Primary completion rate (% of total enrollments) of Guinea in 2001 to that in 2005?
Your response must be concise. 0.68. What is the ratio of the Primary completion rate (% of total enrollments) in Iran in 2001 to that in 2005?
Give a very brief answer. 0.96. What is the ratio of the Primary completion rate (% of total enrollments) in Bulgaria in 2001 to that in 2006?
Give a very brief answer. 1.07. What is the ratio of the Primary completion rate (% of total enrollments) of Guinea in 2001 to that in 2006?
Offer a terse response. 0.64. What is the ratio of the Primary completion rate (% of total enrollments) in Iran in 2001 to that in 2006?
Keep it short and to the point. 0.98. What is the ratio of the Primary completion rate (% of total enrollments) in Tonga in 2001 to that in 2006?
Ensure brevity in your answer.  1.06. What is the ratio of the Primary completion rate (% of total enrollments) of Bulgaria in 2001 to that in 2012?
Provide a succinct answer. 1.05. What is the ratio of the Primary completion rate (% of total enrollments) of Guinea in 2001 to that in 2012?
Your answer should be very brief. 0.66. What is the ratio of the Primary completion rate (% of total enrollments) of Iran in 2001 to that in 2012?
Provide a succinct answer. 0.96. What is the ratio of the Primary completion rate (% of total enrollments) of Tonga in 2001 to that in 2012?
Ensure brevity in your answer.  1.08. What is the ratio of the Primary completion rate (% of total enrollments) in Bulgaria in 2005 to that in 2006?
Offer a terse response. 1.02. What is the ratio of the Primary completion rate (% of total enrollments) of Guinea in 2005 to that in 2006?
Provide a succinct answer. 0.94. What is the ratio of the Primary completion rate (% of total enrollments) in Iran in 2005 to that in 2006?
Your response must be concise. 1.01. What is the ratio of the Primary completion rate (% of total enrollments) of Tonga in 2005 to that in 2006?
Provide a short and direct response. 1.07. What is the ratio of the Primary completion rate (% of total enrollments) of Guinea in 2005 to that in 2012?
Ensure brevity in your answer.  0.96. What is the ratio of the Primary completion rate (% of total enrollments) in Iran in 2005 to that in 2012?
Your answer should be compact. 1. What is the ratio of the Primary completion rate (% of total enrollments) in Tonga in 2005 to that in 2012?
Give a very brief answer. 1.1. What is the ratio of the Primary completion rate (% of total enrollments) of Bulgaria in 2006 to that in 2012?
Give a very brief answer. 0.99. What is the ratio of the Primary completion rate (% of total enrollments) of Guinea in 2006 to that in 2012?
Make the answer very short. 1.02. What is the ratio of the Primary completion rate (% of total enrollments) of Iran in 2006 to that in 2012?
Offer a very short reply. 0.98. What is the ratio of the Primary completion rate (% of total enrollments) in Tonga in 2006 to that in 2012?
Give a very brief answer. 1.02. What is the difference between the highest and the second highest Primary completion rate (% of total enrollments) of Bulgaria?
Offer a very short reply. 4.58. What is the difference between the highest and the second highest Primary completion rate (% of total enrollments) of Guinea?
Keep it short and to the point. 1.35. What is the difference between the highest and the second highest Primary completion rate (% of total enrollments) of Iran?
Provide a short and direct response. 0.47. What is the difference between the highest and the second highest Primary completion rate (% of total enrollments) of Tonga?
Your answer should be compact. 1.12. What is the difference between the highest and the lowest Primary completion rate (% of total enrollments) of Bulgaria?
Offer a very short reply. 17.21. What is the difference between the highest and the lowest Primary completion rate (% of total enrollments) in Guinea?
Ensure brevity in your answer.  42.98. What is the difference between the highest and the lowest Primary completion rate (% of total enrollments) in Iran?
Your answer should be very brief. 9.23. What is the difference between the highest and the lowest Primary completion rate (% of total enrollments) in Tonga?
Your answer should be compact. 9.67. 